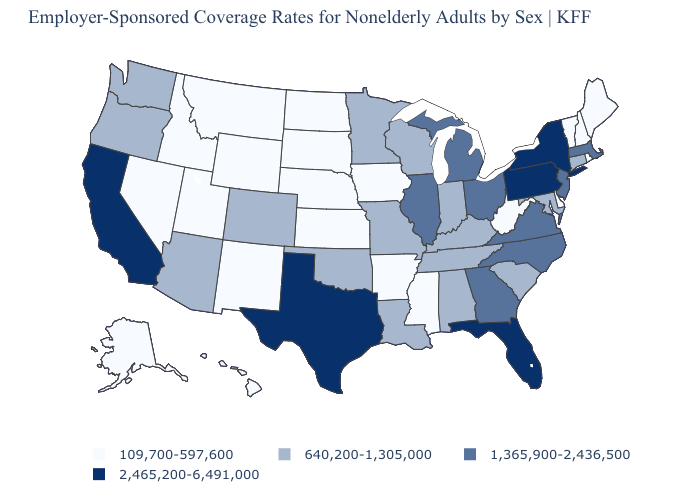Name the states that have a value in the range 1,365,900-2,436,500?
Write a very short answer. Georgia, Illinois, Massachusetts, Michigan, New Jersey, North Carolina, Ohio, Virginia. Name the states that have a value in the range 2,465,200-6,491,000?
Short answer required. California, Florida, New York, Pennsylvania, Texas. How many symbols are there in the legend?
Write a very short answer. 4. Does the map have missing data?
Be succinct. No. Among the states that border Georgia , which have the lowest value?
Write a very short answer. Alabama, South Carolina, Tennessee. What is the lowest value in the USA?
Write a very short answer. 109,700-597,600. Name the states that have a value in the range 1,365,900-2,436,500?
Keep it brief. Georgia, Illinois, Massachusetts, Michigan, New Jersey, North Carolina, Ohio, Virginia. Does the map have missing data?
Answer briefly. No. What is the value of Michigan?
Be succinct. 1,365,900-2,436,500. Among the states that border Missouri , does Kentucky have the highest value?
Write a very short answer. No. What is the lowest value in states that border Wyoming?
Answer briefly. 109,700-597,600. What is the highest value in the USA?
Answer briefly. 2,465,200-6,491,000. What is the value of New Jersey?
Concise answer only. 1,365,900-2,436,500. Name the states that have a value in the range 2,465,200-6,491,000?
Quick response, please. California, Florida, New York, Pennsylvania, Texas. Among the states that border Delaware , does Pennsylvania have the highest value?
Answer briefly. Yes. 